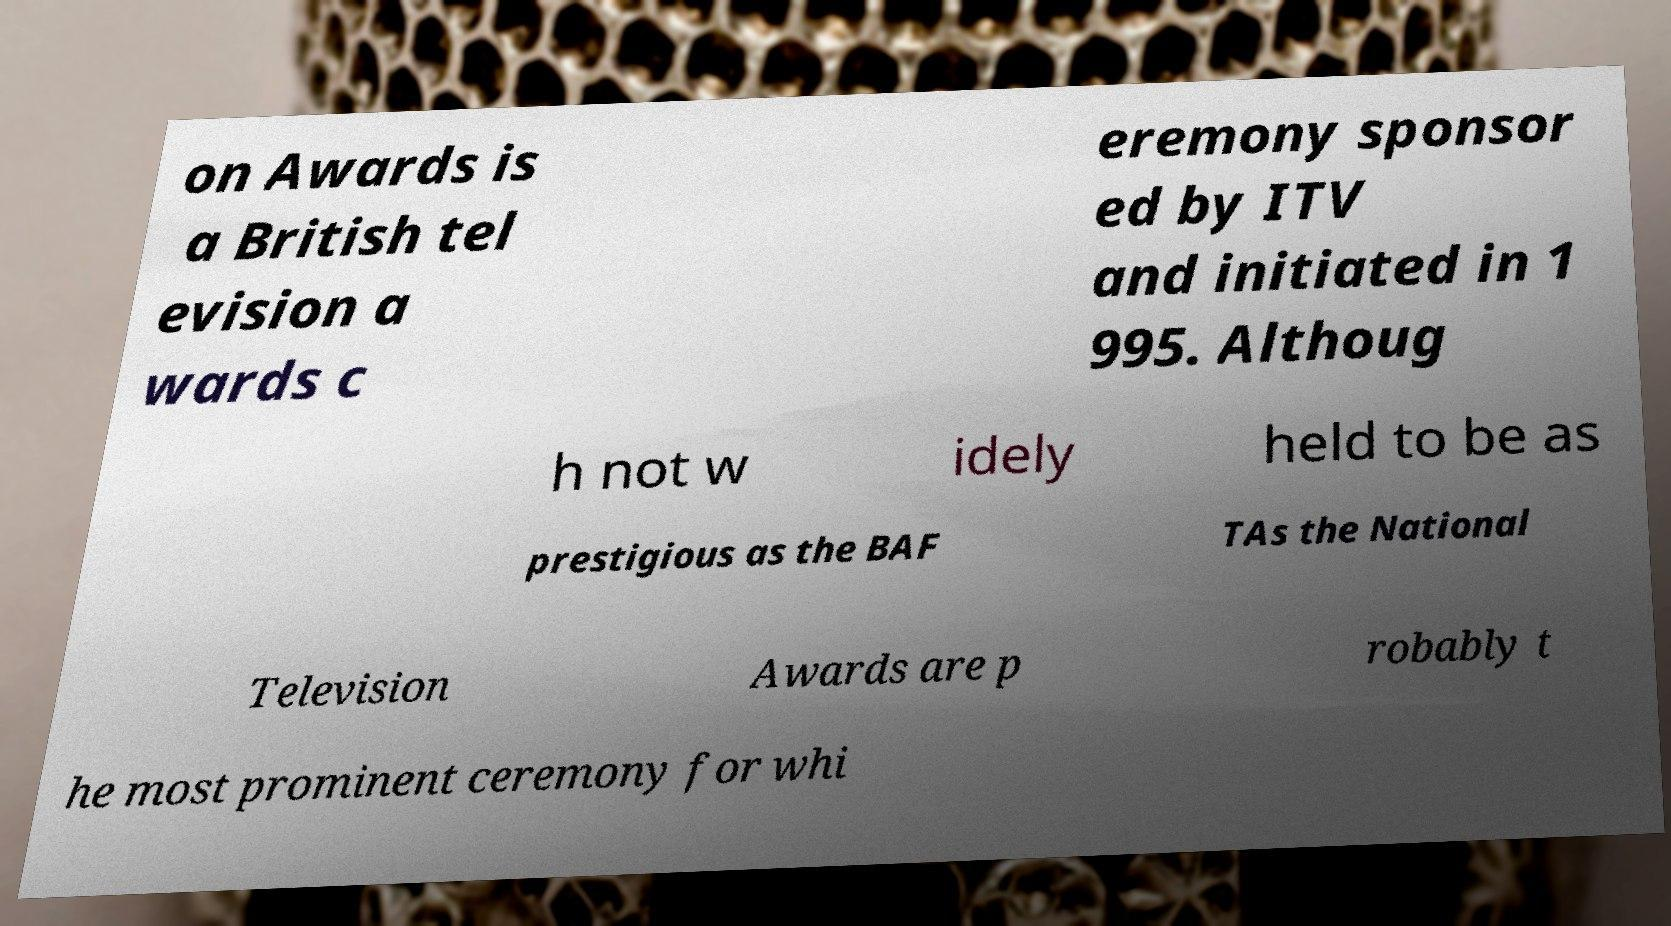What messages or text are displayed in this image? I need them in a readable, typed format. on Awards is a British tel evision a wards c eremony sponsor ed by ITV and initiated in 1 995. Althoug h not w idely held to be as prestigious as the BAF TAs the National Television Awards are p robably t he most prominent ceremony for whi 